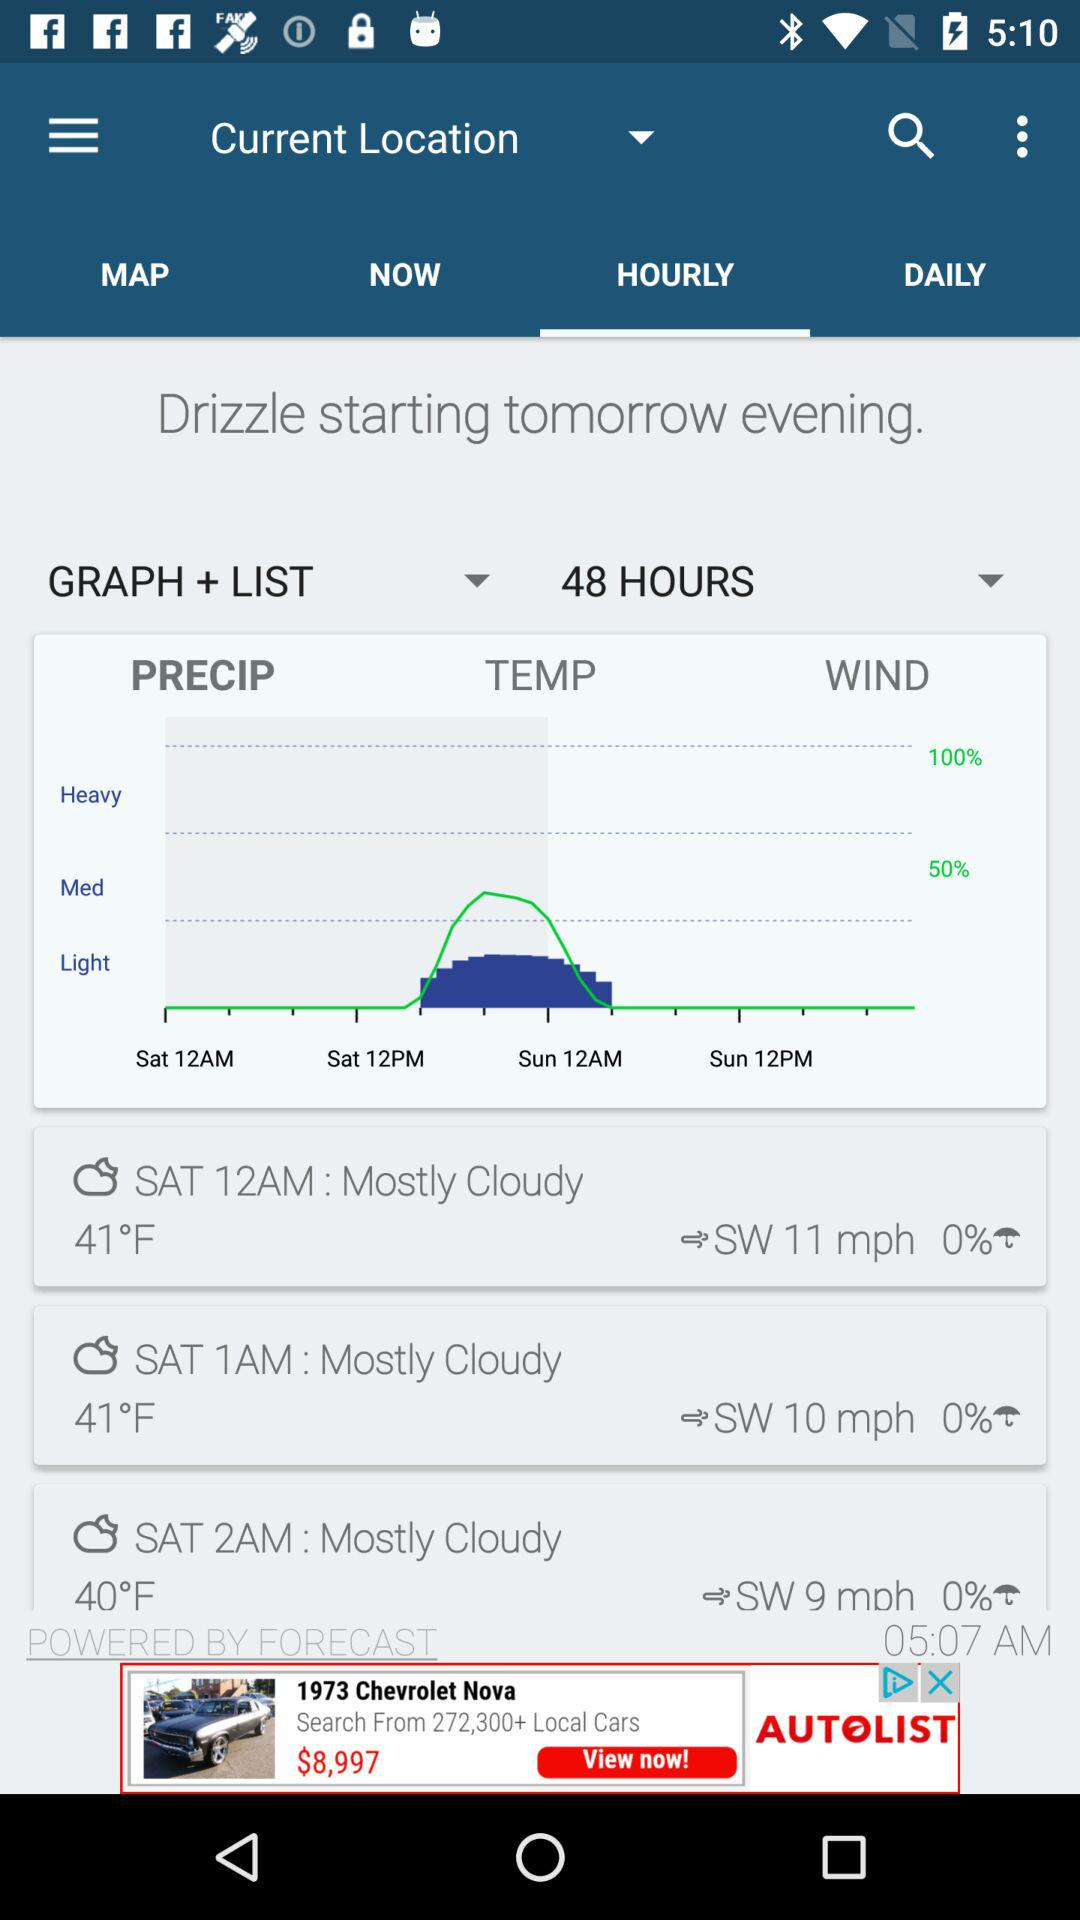What is the difference in temperature between the lowest and highest temperatures shown?
Answer the question using a single word or phrase. 1°F 